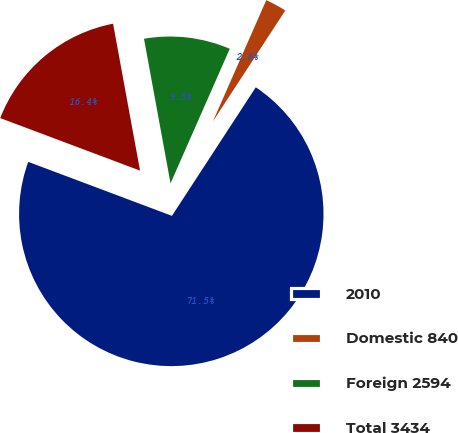<chart> <loc_0><loc_0><loc_500><loc_500><pie_chart><fcel>2010<fcel>Domestic 840<fcel>Foreign 2594<fcel>Total 3434<nl><fcel>71.52%<fcel>2.6%<fcel>9.49%<fcel>16.39%<nl></chart> 